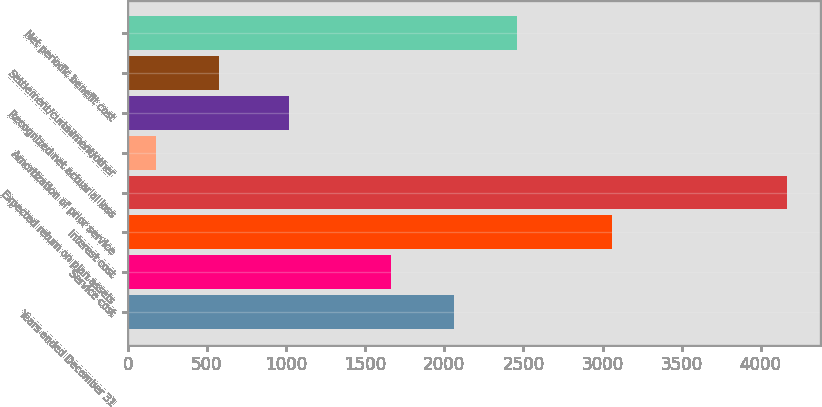Convert chart. <chart><loc_0><loc_0><loc_500><loc_500><bar_chart><fcel>Years ended December 31<fcel>Service cost<fcel>Interest cost<fcel>Expected return on plan assets<fcel>Amortization of prior service<fcel>Recognized net actuarial loss<fcel>Settlement/curtailment/other<fcel>Net periodic benefit cost<nl><fcel>2060.2<fcel>1661<fcel>3058<fcel>4169<fcel>177<fcel>1020<fcel>576.2<fcel>2459.4<nl></chart> 